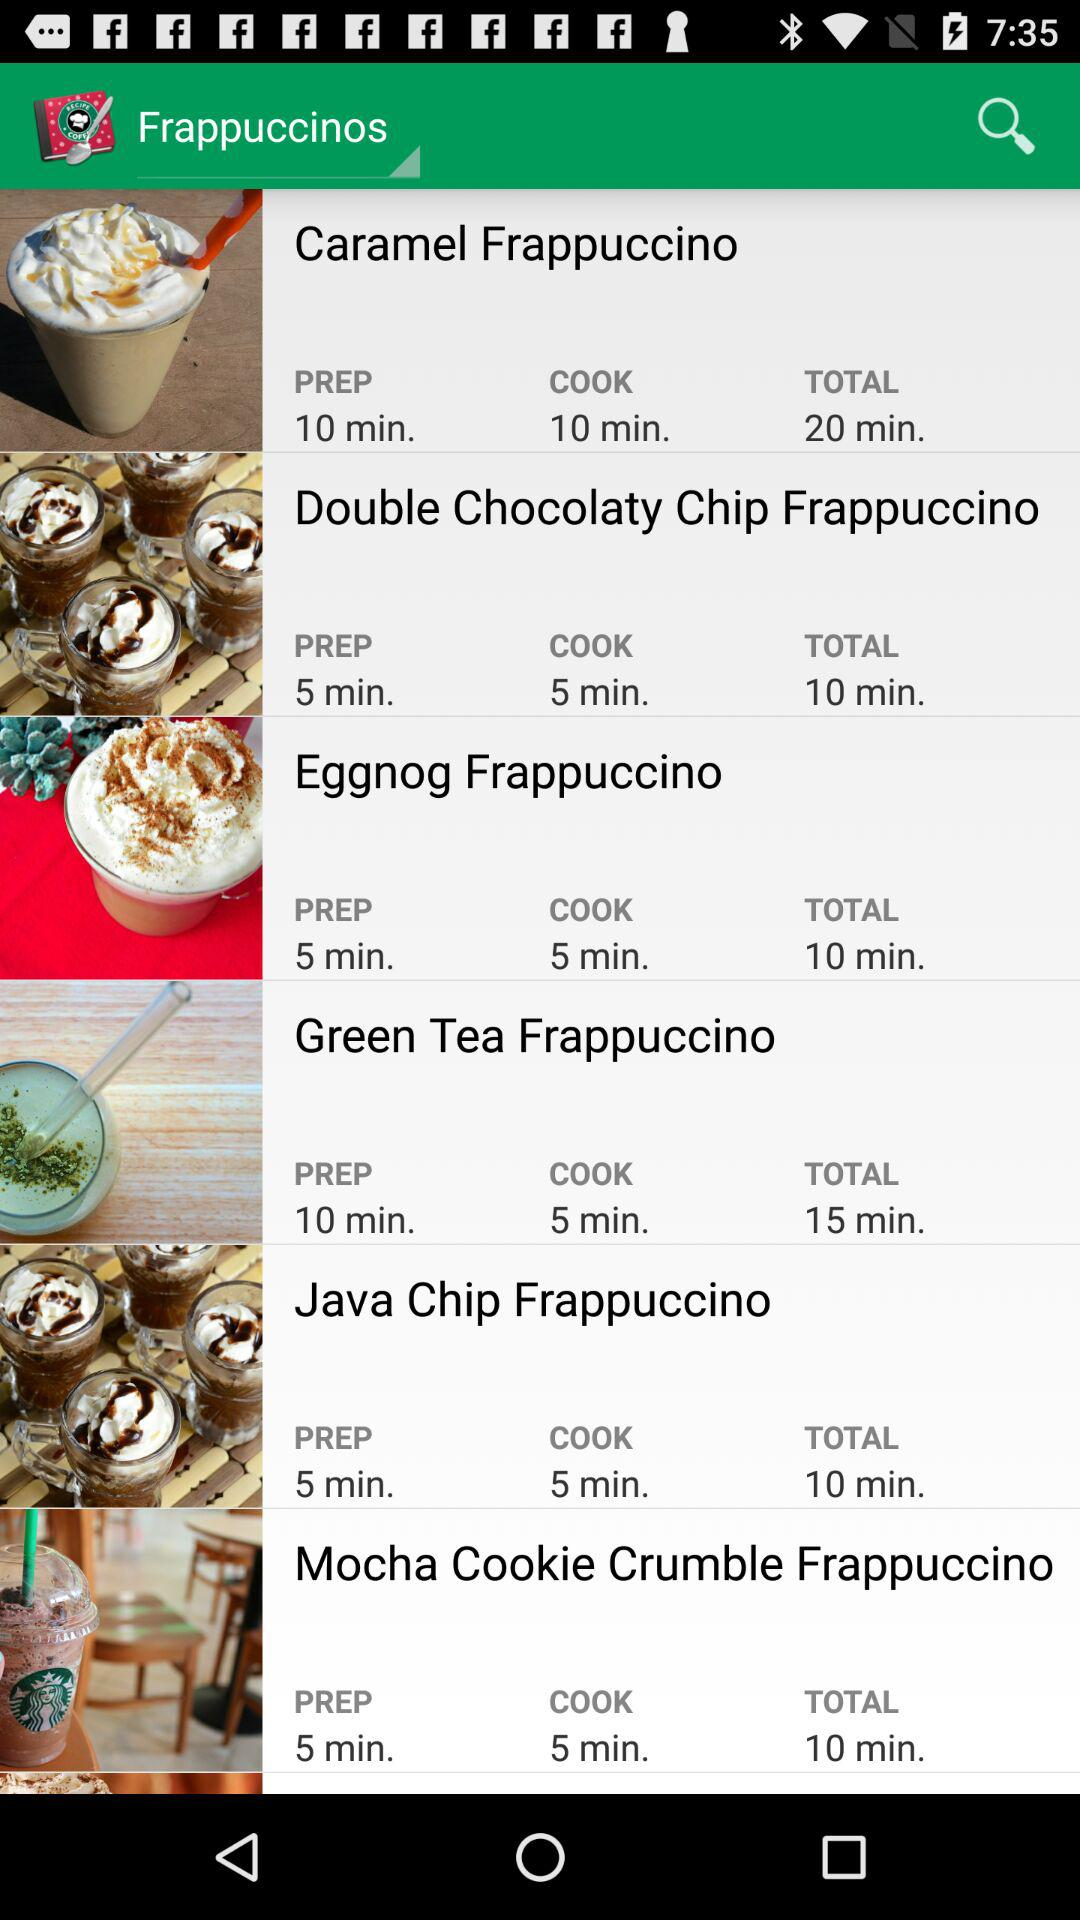How long will it take to make the "Eggnog Frappuccino"? It will take 10 minutes to make the "Eggnog Frappuccino". 